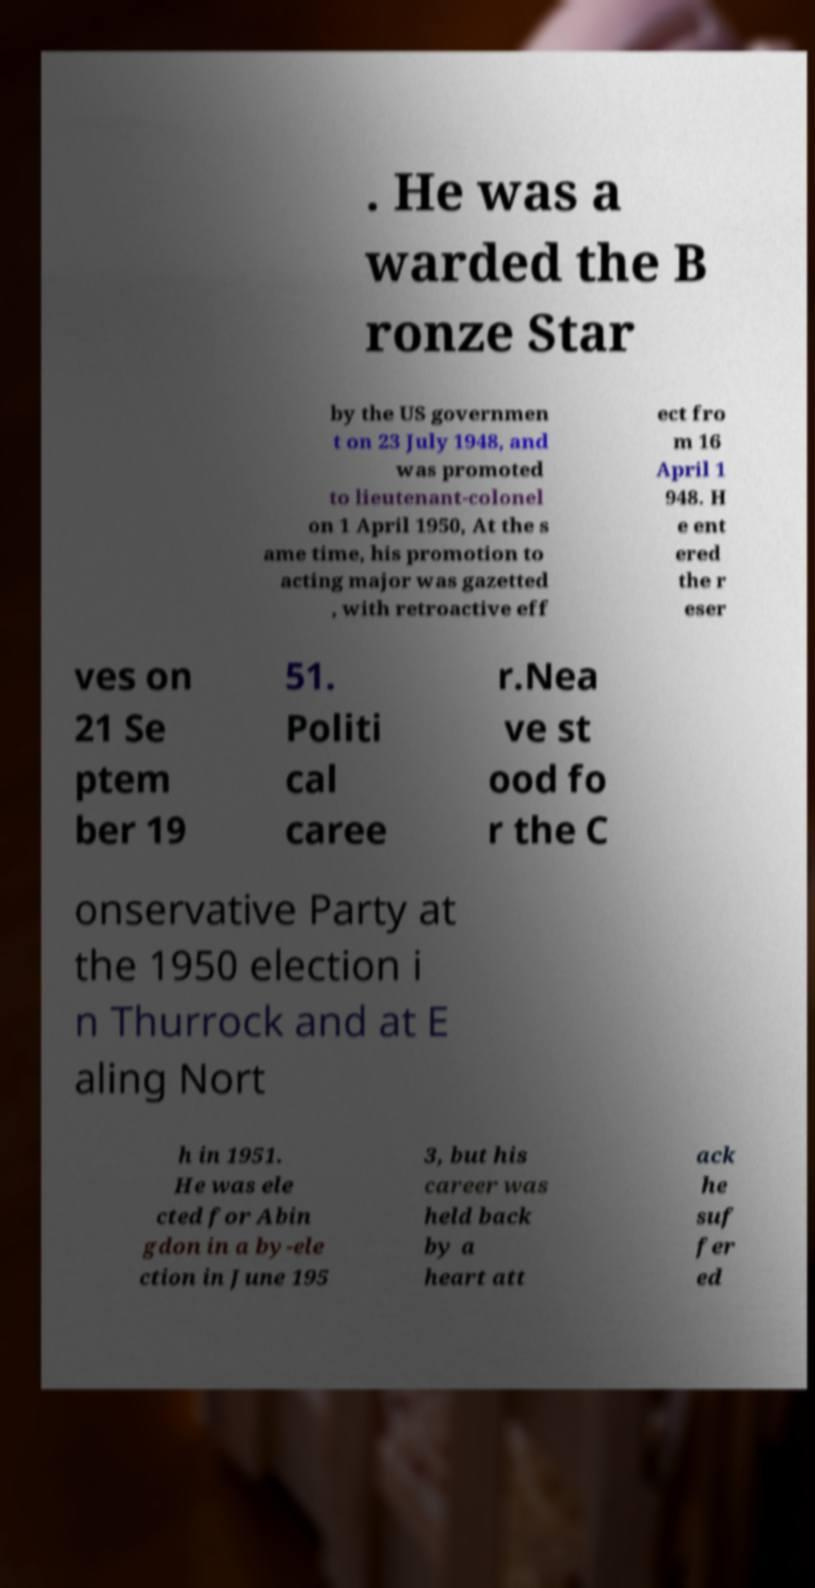Can you read and provide the text displayed in the image?This photo seems to have some interesting text. Can you extract and type it out for me? . He was a warded the B ronze Star by the US governmen t on 23 July 1948, and was promoted to lieutenant-colonel on 1 April 1950, At the s ame time, his promotion to acting major was gazetted , with retroactive eff ect fro m 16 April 1 948. H e ent ered the r eser ves on 21 Se ptem ber 19 51. Politi cal caree r.Nea ve st ood fo r the C onservative Party at the 1950 election i n Thurrock and at E aling Nort h in 1951. He was ele cted for Abin gdon in a by-ele ction in June 195 3, but his career was held back by a heart att ack he suf fer ed 